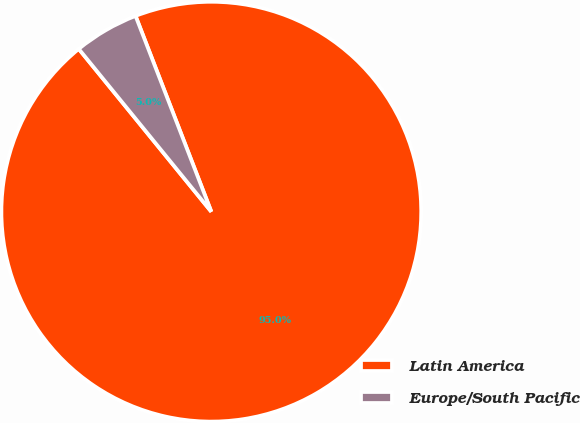<chart> <loc_0><loc_0><loc_500><loc_500><pie_chart><fcel>Latin America<fcel>Europe/South Pacific<nl><fcel>95.0%<fcel>5.0%<nl></chart> 